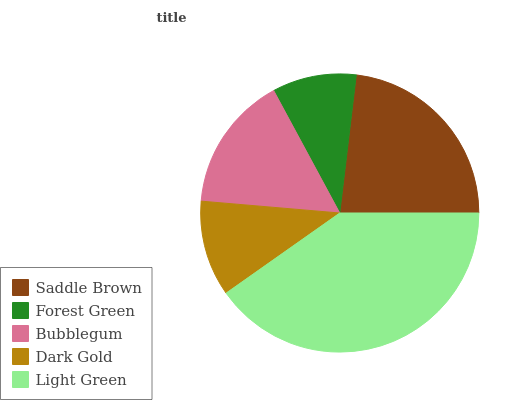Is Forest Green the minimum?
Answer yes or no. Yes. Is Light Green the maximum?
Answer yes or no. Yes. Is Bubblegum the minimum?
Answer yes or no. No. Is Bubblegum the maximum?
Answer yes or no. No. Is Bubblegum greater than Forest Green?
Answer yes or no. Yes. Is Forest Green less than Bubblegum?
Answer yes or no. Yes. Is Forest Green greater than Bubblegum?
Answer yes or no. No. Is Bubblegum less than Forest Green?
Answer yes or no. No. Is Bubblegum the high median?
Answer yes or no. Yes. Is Bubblegum the low median?
Answer yes or no. Yes. Is Forest Green the high median?
Answer yes or no. No. Is Forest Green the low median?
Answer yes or no. No. 